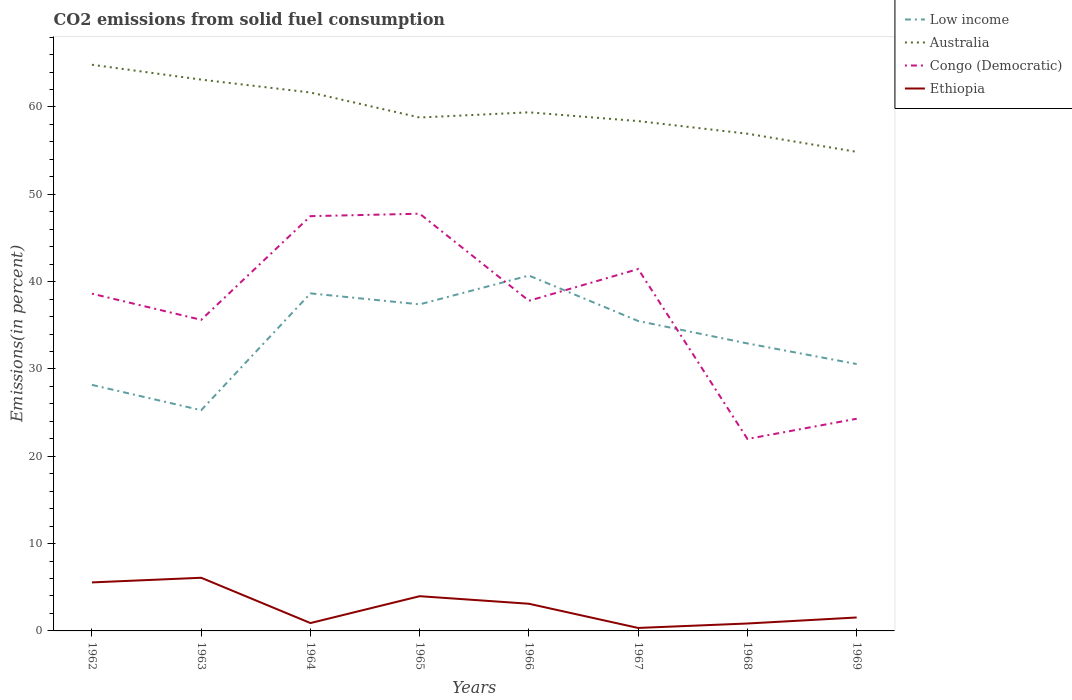Does the line corresponding to Ethiopia intersect with the line corresponding to Low income?
Your response must be concise. No. Across all years, what is the maximum total CO2 emitted in Australia?
Your answer should be compact. 54.86. In which year was the total CO2 emitted in Ethiopia maximum?
Ensure brevity in your answer.  1967. What is the total total CO2 emitted in Ethiopia in the graph?
Give a very brief answer. 3.64. What is the difference between the highest and the second highest total CO2 emitted in Ethiopia?
Your response must be concise. 5.75. What is the difference between the highest and the lowest total CO2 emitted in Low income?
Keep it short and to the point. 4. Is the total CO2 emitted in Ethiopia strictly greater than the total CO2 emitted in Low income over the years?
Offer a terse response. Yes. How many lines are there?
Provide a short and direct response. 4. How many legend labels are there?
Your answer should be very brief. 4. What is the title of the graph?
Make the answer very short. CO2 emissions from solid fuel consumption. Does "Sub-Saharan Africa (developing only)" appear as one of the legend labels in the graph?
Ensure brevity in your answer.  No. What is the label or title of the Y-axis?
Offer a very short reply. Emissions(in percent). What is the Emissions(in percent) in Low income in 1962?
Make the answer very short. 28.17. What is the Emissions(in percent) of Australia in 1962?
Give a very brief answer. 64.83. What is the Emissions(in percent) of Congo (Democratic) in 1962?
Your answer should be very brief. 38.62. What is the Emissions(in percent) in Ethiopia in 1962?
Offer a very short reply. 5.56. What is the Emissions(in percent) in Low income in 1963?
Give a very brief answer. 25.27. What is the Emissions(in percent) of Australia in 1963?
Provide a short and direct response. 63.13. What is the Emissions(in percent) of Congo (Democratic) in 1963?
Make the answer very short. 35.62. What is the Emissions(in percent) in Ethiopia in 1963?
Give a very brief answer. 6.09. What is the Emissions(in percent) in Low income in 1964?
Keep it short and to the point. 38.65. What is the Emissions(in percent) of Australia in 1964?
Ensure brevity in your answer.  61.65. What is the Emissions(in percent) in Congo (Democratic) in 1964?
Ensure brevity in your answer.  47.5. What is the Emissions(in percent) in Ethiopia in 1964?
Make the answer very short. 0.9. What is the Emissions(in percent) in Low income in 1965?
Provide a succinct answer. 37.4. What is the Emissions(in percent) in Australia in 1965?
Offer a very short reply. 58.79. What is the Emissions(in percent) of Congo (Democratic) in 1965?
Make the answer very short. 47.77. What is the Emissions(in percent) of Ethiopia in 1965?
Give a very brief answer. 3.98. What is the Emissions(in percent) of Low income in 1966?
Your answer should be compact. 40.69. What is the Emissions(in percent) of Australia in 1966?
Your response must be concise. 59.38. What is the Emissions(in percent) in Congo (Democratic) in 1966?
Give a very brief answer. 37.8. What is the Emissions(in percent) in Ethiopia in 1966?
Make the answer very short. 3.11. What is the Emissions(in percent) of Low income in 1967?
Keep it short and to the point. 35.49. What is the Emissions(in percent) of Australia in 1967?
Provide a short and direct response. 58.38. What is the Emissions(in percent) in Congo (Democratic) in 1967?
Keep it short and to the point. 41.44. What is the Emissions(in percent) in Ethiopia in 1967?
Keep it short and to the point. 0.34. What is the Emissions(in percent) in Low income in 1968?
Give a very brief answer. 32.92. What is the Emissions(in percent) of Australia in 1968?
Offer a terse response. 56.94. What is the Emissions(in percent) in Congo (Democratic) in 1968?
Make the answer very short. 21.98. What is the Emissions(in percent) of Ethiopia in 1968?
Offer a very short reply. 0.85. What is the Emissions(in percent) in Low income in 1969?
Your answer should be very brief. 30.56. What is the Emissions(in percent) of Australia in 1969?
Your answer should be very brief. 54.86. What is the Emissions(in percent) in Congo (Democratic) in 1969?
Make the answer very short. 24.3. What is the Emissions(in percent) of Ethiopia in 1969?
Your answer should be very brief. 1.54. Across all years, what is the maximum Emissions(in percent) of Low income?
Your answer should be compact. 40.69. Across all years, what is the maximum Emissions(in percent) in Australia?
Offer a terse response. 64.83. Across all years, what is the maximum Emissions(in percent) in Congo (Democratic)?
Your answer should be compact. 47.77. Across all years, what is the maximum Emissions(in percent) in Ethiopia?
Your answer should be very brief. 6.09. Across all years, what is the minimum Emissions(in percent) of Low income?
Your answer should be compact. 25.27. Across all years, what is the minimum Emissions(in percent) of Australia?
Ensure brevity in your answer.  54.86. Across all years, what is the minimum Emissions(in percent) in Congo (Democratic)?
Ensure brevity in your answer.  21.98. Across all years, what is the minimum Emissions(in percent) of Ethiopia?
Make the answer very short. 0.34. What is the total Emissions(in percent) in Low income in the graph?
Offer a terse response. 269.16. What is the total Emissions(in percent) in Australia in the graph?
Your response must be concise. 477.97. What is the total Emissions(in percent) in Congo (Democratic) in the graph?
Provide a succinct answer. 295.03. What is the total Emissions(in percent) in Ethiopia in the graph?
Ensure brevity in your answer.  22.36. What is the difference between the Emissions(in percent) in Low income in 1962 and that in 1963?
Offer a terse response. 2.9. What is the difference between the Emissions(in percent) of Australia in 1962 and that in 1963?
Your answer should be compact. 1.7. What is the difference between the Emissions(in percent) of Congo (Democratic) in 1962 and that in 1963?
Ensure brevity in your answer.  2.99. What is the difference between the Emissions(in percent) in Ethiopia in 1962 and that in 1963?
Offer a very short reply. -0.53. What is the difference between the Emissions(in percent) of Low income in 1962 and that in 1964?
Keep it short and to the point. -10.48. What is the difference between the Emissions(in percent) of Australia in 1962 and that in 1964?
Your answer should be compact. 3.18. What is the difference between the Emissions(in percent) of Congo (Democratic) in 1962 and that in 1964?
Your answer should be compact. -8.88. What is the difference between the Emissions(in percent) of Ethiopia in 1962 and that in 1964?
Offer a very short reply. 4.65. What is the difference between the Emissions(in percent) in Low income in 1962 and that in 1965?
Provide a short and direct response. -9.22. What is the difference between the Emissions(in percent) of Australia in 1962 and that in 1965?
Your answer should be compact. 6.04. What is the difference between the Emissions(in percent) in Congo (Democratic) in 1962 and that in 1965?
Keep it short and to the point. -9.16. What is the difference between the Emissions(in percent) in Ethiopia in 1962 and that in 1965?
Give a very brief answer. 1.58. What is the difference between the Emissions(in percent) in Low income in 1962 and that in 1966?
Provide a succinct answer. -12.52. What is the difference between the Emissions(in percent) of Australia in 1962 and that in 1966?
Keep it short and to the point. 5.45. What is the difference between the Emissions(in percent) in Congo (Democratic) in 1962 and that in 1966?
Keep it short and to the point. 0.81. What is the difference between the Emissions(in percent) of Ethiopia in 1962 and that in 1966?
Make the answer very short. 2.44. What is the difference between the Emissions(in percent) of Low income in 1962 and that in 1967?
Provide a succinct answer. -7.31. What is the difference between the Emissions(in percent) of Australia in 1962 and that in 1967?
Provide a succinct answer. 6.45. What is the difference between the Emissions(in percent) in Congo (Democratic) in 1962 and that in 1967?
Provide a short and direct response. -2.82. What is the difference between the Emissions(in percent) of Ethiopia in 1962 and that in 1967?
Give a very brief answer. 5.21. What is the difference between the Emissions(in percent) of Low income in 1962 and that in 1968?
Provide a short and direct response. -4.75. What is the difference between the Emissions(in percent) in Australia in 1962 and that in 1968?
Provide a short and direct response. 7.9. What is the difference between the Emissions(in percent) in Congo (Democratic) in 1962 and that in 1968?
Provide a succinct answer. 16.64. What is the difference between the Emissions(in percent) of Ethiopia in 1962 and that in 1968?
Ensure brevity in your answer.  4.71. What is the difference between the Emissions(in percent) of Low income in 1962 and that in 1969?
Provide a short and direct response. -2.39. What is the difference between the Emissions(in percent) of Australia in 1962 and that in 1969?
Make the answer very short. 9.98. What is the difference between the Emissions(in percent) of Congo (Democratic) in 1962 and that in 1969?
Your answer should be compact. 14.32. What is the difference between the Emissions(in percent) in Ethiopia in 1962 and that in 1969?
Give a very brief answer. 4.02. What is the difference between the Emissions(in percent) of Low income in 1963 and that in 1964?
Keep it short and to the point. -13.38. What is the difference between the Emissions(in percent) of Australia in 1963 and that in 1964?
Your response must be concise. 1.48. What is the difference between the Emissions(in percent) in Congo (Democratic) in 1963 and that in 1964?
Provide a short and direct response. -11.87. What is the difference between the Emissions(in percent) in Ethiopia in 1963 and that in 1964?
Offer a very short reply. 5.19. What is the difference between the Emissions(in percent) of Low income in 1963 and that in 1965?
Provide a succinct answer. -12.12. What is the difference between the Emissions(in percent) in Australia in 1963 and that in 1965?
Keep it short and to the point. 4.34. What is the difference between the Emissions(in percent) in Congo (Democratic) in 1963 and that in 1965?
Ensure brevity in your answer.  -12.15. What is the difference between the Emissions(in percent) in Ethiopia in 1963 and that in 1965?
Offer a terse response. 2.11. What is the difference between the Emissions(in percent) of Low income in 1963 and that in 1966?
Your answer should be compact. -15.42. What is the difference between the Emissions(in percent) in Australia in 1963 and that in 1966?
Give a very brief answer. 3.75. What is the difference between the Emissions(in percent) in Congo (Democratic) in 1963 and that in 1966?
Your answer should be very brief. -2.18. What is the difference between the Emissions(in percent) in Ethiopia in 1963 and that in 1966?
Your answer should be very brief. 2.98. What is the difference between the Emissions(in percent) in Low income in 1963 and that in 1967?
Give a very brief answer. -10.21. What is the difference between the Emissions(in percent) in Australia in 1963 and that in 1967?
Ensure brevity in your answer.  4.75. What is the difference between the Emissions(in percent) in Congo (Democratic) in 1963 and that in 1967?
Your response must be concise. -5.82. What is the difference between the Emissions(in percent) of Ethiopia in 1963 and that in 1967?
Your answer should be very brief. 5.75. What is the difference between the Emissions(in percent) of Low income in 1963 and that in 1968?
Your answer should be very brief. -7.65. What is the difference between the Emissions(in percent) of Australia in 1963 and that in 1968?
Your answer should be compact. 6.2. What is the difference between the Emissions(in percent) in Congo (Democratic) in 1963 and that in 1968?
Ensure brevity in your answer.  13.64. What is the difference between the Emissions(in percent) of Ethiopia in 1963 and that in 1968?
Keep it short and to the point. 5.24. What is the difference between the Emissions(in percent) of Low income in 1963 and that in 1969?
Your answer should be compact. -5.29. What is the difference between the Emissions(in percent) in Australia in 1963 and that in 1969?
Keep it short and to the point. 8.27. What is the difference between the Emissions(in percent) in Congo (Democratic) in 1963 and that in 1969?
Your answer should be very brief. 11.33. What is the difference between the Emissions(in percent) in Ethiopia in 1963 and that in 1969?
Your response must be concise. 4.55. What is the difference between the Emissions(in percent) in Low income in 1964 and that in 1965?
Provide a succinct answer. 1.26. What is the difference between the Emissions(in percent) of Australia in 1964 and that in 1965?
Provide a short and direct response. 2.86. What is the difference between the Emissions(in percent) of Congo (Democratic) in 1964 and that in 1965?
Offer a terse response. -0.28. What is the difference between the Emissions(in percent) of Ethiopia in 1964 and that in 1965?
Your response must be concise. -3.08. What is the difference between the Emissions(in percent) in Low income in 1964 and that in 1966?
Give a very brief answer. -2.04. What is the difference between the Emissions(in percent) of Australia in 1964 and that in 1966?
Make the answer very short. 2.27. What is the difference between the Emissions(in percent) of Congo (Democratic) in 1964 and that in 1966?
Offer a very short reply. 9.69. What is the difference between the Emissions(in percent) in Ethiopia in 1964 and that in 1966?
Offer a very short reply. -2.21. What is the difference between the Emissions(in percent) of Low income in 1964 and that in 1967?
Your response must be concise. 3.16. What is the difference between the Emissions(in percent) in Australia in 1964 and that in 1967?
Make the answer very short. 3.27. What is the difference between the Emissions(in percent) in Congo (Democratic) in 1964 and that in 1967?
Provide a succinct answer. 6.06. What is the difference between the Emissions(in percent) in Ethiopia in 1964 and that in 1967?
Offer a very short reply. 0.56. What is the difference between the Emissions(in percent) in Low income in 1964 and that in 1968?
Provide a succinct answer. 5.73. What is the difference between the Emissions(in percent) in Australia in 1964 and that in 1968?
Provide a short and direct response. 4.72. What is the difference between the Emissions(in percent) of Congo (Democratic) in 1964 and that in 1968?
Your response must be concise. 25.51. What is the difference between the Emissions(in percent) of Ethiopia in 1964 and that in 1968?
Provide a short and direct response. 0.05. What is the difference between the Emissions(in percent) in Low income in 1964 and that in 1969?
Make the answer very short. 8.09. What is the difference between the Emissions(in percent) of Australia in 1964 and that in 1969?
Make the answer very short. 6.8. What is the difference between the Emissions(in percent) in Congo (Democratic) in 1964 and that in 1969?
Make the answer very short. 23.2. What is the difference between the Emissions(in percent) in Ethiopia in 1964 and that in 1969?
Ensure brevity in your answer.  -0.64. What is the difference between the Emissions(in percent) of Low income in 1965 and that in 1966?
Give a very brief answer. -3.3. What is the difference between the Emissions(in percent) of Australia in 1965 and that in 1966?
Offer a very short reply. -0.59. What is the difference between the Emissions(in percent) of Congo (Democratic) in 1965 and that in 1966?
Offer a very short reply. 9.97. What is the difference between the Emissions(in percent) of Ethiopia in 1965 and that in 1966?
Give a very brief answer. 0.87. What is the difference between the Emissions(in percent) of Low income in 1965 and that in 1967?
Make the answer very short. 1.91. What is the difference between the Emissions(in percent) of Australia in 1965 and that in 1967?
Make the answer very short. 0.41. What is the difference between the Emissions(in percent) in Congo (Democratic) in 1965 and that in 1967?
Offer a terse response. 6.33. What is the difference between the Emissions(in percent) of Ethiopia in 1965 and that in 1967?
Provide a succinct answer. 3.64. What is the difference between the Emissions(in percent) of Low income in 1965 and that in 1968?
Provide a succinct answer. 4.48. What is the difference between the Emissions(in percent) in Australia in 1965 and that in 1968?
Your response must be concise. 1.86. What is the difference between the Emissions(in percent) of Congo (Democratic) in 1965 and that in 1968?
Provide a short and direct response. 25.79. What is the difference between the Emissions(in percent) in Ethiopia in 1965 and that in 1968?
Offer a terse response. 3.13. What is the difference between the Emissions(in percent) in Low income in 1965 and that in 1969?
Your response must be concise. 6.84. What is the difference between the Emissions(in percent) of Australia in 1965 and that in 1969?
Offer a very short reply. 3.93. What is the difference between the Emissions(in percent) in Congo (Democratic) in 1965 and that in 1969?
Provide a short and direct response. 23.48. What is the difference between the Emissions(in percent) of Ethiopia in 1965 and that in 1969?
Ensure brevity in your answer.  2.44. What is the difference between the Emissions(in percent) of Low income in 1966 and that in 1967?
Your answer should be very brief. 5.21. What is the difference between the Emissions(in percent) in Congo (Democratic) in 1966 and that in 1967?
Keep it short and to the point. -3.64. What is the difference between the Emissions(in percent) of Ethiopia in 1966 and that in 1967?
Provide a succinct answer. 2.77. What is the difference between the Emissions(in percent) in Low income in 1966 and that in 1968?
Ensure brevity in your answer.  7.77. What is the difference between the Emissions(in percent) of Australia in 1966 and that in 1968?
Provide a succinct answer. 2.45. What is the difference between the Emissions(in percent) of Congo (Democratic) in 1966 and that in 1968?
Provide a succinct answer. 15.82. What is the difference between the Emissions(in percent) in Ethiopia in 1966 and that in 1968?
Give a very brief answer. 2.26. What is the difference between the Emissions(in percent) in Low income in 1966 and that in 1969?
Ensure brevity in your answer.  10.13. What is the difference between the Emissions(in percent) of Australia in 1966 and that in 1969?
Your answer should be very brief. 4.53. What is the difference between the Emissions(in percent) of Congo (Democratic) in 1966 and that in 1969?
Make the answer very short. 13.51. What is the difference between the Emissions(in percent) in Ethiopia in 1966 and that in 1969?
Your answer should be very brief. 1.57. What is the difference between the Emissions(in percent) in Low income in 1967 and that in 1968?
Offer a terse response. 2.57. What is the difference between the Emissions(in percent) in Australia in 1967 and that in 1968?
Keep it short and to the point. 1.45. What is the difference between the Emissions(in percent) in Congo (Democratic) in 1967 and that in 1968?
Keep it short and to the point. 19.46. What is the difference between the Emissions(in percent) in Ethiopia in 1967 and that in 1968?
Your answer should be compact. -0.51. What is the difference between the Emissions(in percent) in Low income in 1967 and that in 1969?
Offer a terse response. 4.93. What is the difference between the Emissions(in percent) in Australia in 1967 and that in 1969?
Keep it short and to the point. 3.52. What is the difference between the Emissions(in percent) in Congo (Democratic) in 1967 and that in 1969?
Offer a terse response. 17.14. What is the difference between the Emissions(in percent) of Ethiopia in 1967 and that in 1969?
Make the answer very short. -1.2. What is the difference between the Emissions(in percent) of Low income in 1968 and that in 1969?
Offer a very short reply. 2.36. What is the difference between the Emissions(in percent) in Australia in 1968 and that in 1969?
Keep it short and to the point. 2.08. What is the difference between the Emissions(in percent) in Congo (Democratic) in 1968 and that in 1969?
Provide a succinct answer. -2.32. What is the difference between the Emissions(in percent) of Ethiopia in 1968 and that in 1969?
Provide a short and direct response. -0.69. What is the difference between the Emissions(in percent) in Low income in 1962 and the Emissions(in percent) in Australia in 1963?
Ensure brevity in your answer.  -34.96. What is the difference between the Emissions(in percent) in Low income in 1962 and the Emissions(in percent) in Congo (Democratic) in 1963?
Give a very brief answer. -7.45. What is the difference between the Emissions(in percent) in Low income in 1962 and the Emissions(in percent) in Ethiopia in 1963?
Your answer should be compact. 22.09. What is the difference between the Emissions(in percent) in Australia in 1962 and the Emissions(in percent) in Congo (Democratic) in 1963?
Provide a succinct answer. 29.21. What is the difference between the Emissions(in percent) of Australia in 1962 and the Emissions(in percent) of Ethiopia in 1963?
Keep it short and to the point. 58.75. What is the difference between the Emissions(in percent) of Congo (Democratic) in 1962 and the Emissions(in percent) of Ethiopia in 1963?
Give a very brief answer. 32.53. What is the difference between the Emissions(in percent) in Low income in 1962 and the Emissions(in percent) in Australia in 1964?
Make the answer very short. -33.48. What is the difference between the Emissions(in percent) in Low income in 1962 and the Emissions(in percent) in Congo (Democratic) in 1964?
Offer a terse response. -19.32. What is the difference between the Emissions(in percent) in Low income in 1962 and the Emissions(in percent) in Ethiopia in 1964?
Keep it short and to the point. 27.27. What is the difference between the Emissions(in percent) of Australia in 1962 and the Emissions(in percent) of Congo (Democratic) in 1964?
Ensure brevity in your answer.  17.34. What is the difference between the Emissions(in percent) in Australia in 1962 and the Emissions(in percent) in Ethiopia in 1964?
Give a very brief answer. 63.93. What is the difference between the Emissions(in percent) of Congo (Democratic) in 1962 and the Emissions(in percent) of Ethiopia in 1964?
Your response must be concise. 37.72. What is the difference between the Emissions(in percent) of Low income in 1962 and the Emissions(in percent) of Australia in 1965?
Your response must be concise. -30.62. What is the difference between the Emissions(in percent) in Low income in 1962 and the Emissions(in percent) in Congo (Democratic) in 1965?
Your response must be concise. -19.6. What is the difference between the Emissions(in percent) in Low income in 1962 and the Emissions(in percent) in Ethiopia in 1965?
Provide a short and direct response. 24.2. What is the difference between the Emissions(in percent) of Australia in 1962 and the Emissions(in percent) of Congo (Democratic) in 1965?
Make the answer very short. 17.06. What is the difference between the Emissions(in percent) of Australia in 1962 and the Emissions(in percent) of Ethiopia in 1965?
Make the answer very short. 60.86. What is the difference between the Emissions(in percent) in Congo (Democratic) in 1962 and the Emissions(in percent) in Ethiopia in 1965?
Keep it short and to the point. 34.64. What is the difference between the Emissions(in percent) of Low income in 1962 and the Emissions(in percent) of Australia in 1966?
Your response must be concise. -31.21. What is the difference between the Emissions(in percent) of Low income in 1962 and the Emissions(in percent) of Congo (Democratic) in 1966?
Offer a very short reply. -9.63. What is the difference between the Emissions(in percent) of Low income in 1962 and the Emissions(in percent) of Ethiopia in 1966?
Provide a succinct answer. 25.06. What is the difference between the Emissions(in percent) of Australia in 1962 and the Emissions(in percent) of Congo (Democratic) in 1966?
Your answer should be very brief. 27.03. What is the difference between the Emissions(in percent) in Australia in 1962 and the Emissions(in percent) in Ethiopia in 1966?
Your answer should be compact. 61.72. What is the difference between the Emissions(in percent) in Congo (Democratic) in 1962 and the Emissions(in percent) in Ethiopia in 1966?
Provide a succinct answer. 35.51. What is the difference between the Emissions(in percent) in Low income in 1962 and the Emissions(in percent) in Australia in 1967?
Your response must be concise. -30.21. What is the difference between the Emissions(in percent) in Low income in 1962 and the Emissions(in percent) in Congo (Democratic) in 1967?
Your response must be concise. -13.27. What is the difference between the Emissions(in percent) of Low income in 1962 and the Emissions(in percent) of Ethiopia in 1967?
Your answer should be compact. 27.83. What is the difference between the Emissions(in percent) in Australia in 1962 and the Emissions(in percent) in Congo (Democratic) in 1967?
Offer a very short reply. 23.39. What is the difference between the Emissions(in percent) of Australia in 1962 and the Emissions(in percent) of Ethiopia in 1967?
Your answer should be very brief. 64.49. What is the difference between the Emissions(in percent) in Congo (Democratic) in 1962 and the Emissions(in percent) in Ethiopia in 1967?
Make the answer very short. 38.28. What is the difference between the Emissions(in percent) in Low income in 1962 and the Emissions(in percent) in Australia in 1968?
Provide a succinct answer. -28.76. What is the difference between the Emissions(in percent) of Low income in 1962 and the Emissions(in percent) of Congo (Democratic) in 1968?
Your answer should be compact. 6.19. What is the difference between the Emissions(in percent) of Low income in 1962 and the Emissions(in percent) of Ethiopia in 1968?
Keep it short and to the point. 27.32. What is the difference between the Emissions(in percent) of Australia in 1962 and the Emissions(in percent) of Congo (Democratic) in 1968?
Your answer should be very brief. 42.85. What is the difference between the Emissions(in percent) of Australia in 1962 and the Emissions(in percent) of Ethiopia in 1968?
Keep it short and to the point. 63.98. What is the difference between the Emissions(in percent) of Congo (Democratic) in 1962 and the Emissions(in percent) of Ethiopia in 1968?
Give a very brief answer. 37.77. What is the difference between the Emissions(in percent) of Low income in 1962 and the Emissions(in percent) of Australia in 1969?
Make the answer very short. -26.68. What is the difference between the Emissions(in percent) in Low income in 1962 and the Emissions(in percent) in Congo (Democratic) in 1969?
Your answer should be compact. 3.88. What is the difference between the Emissions(in percent) of Low income in 1962 and the Emissions(in percent) of Ethiopia in 1969?
Give a very brief answer. 26.64. What is the difference between the Emissions(in percent) in Australia in 1962 and the Emissions(in percent) in Congo (Democratic) in 1969?
Your answer should be compact. 40.54. What is the difference between the Emissions(in percent) of Australia in 1962 and the Emissions(in percent) of Ethiopia in 1969?
Provide a succinct answer. 63.3. What is the difference between the Emissions(in percent) of Congo (Democratic) in 1962 and the Emissions(in percent) of Ethiopia in 1969?
Your response must be concise. 37.08. What is the difference between the Emissions(in percent) in Low income in 1963 and the Emissions(in percent) in Australia in 1964?
Provide a short and direct response. -36.38. What is the difference between the Emissions(in percent) in Low income in 1963 and the Emissions(in percent) in Congo (Democratic) in 1964?
Ensure brevity in your answer.  -22.22. What is the difference between the Emissions(in percent) in Low income in 1963 and the Emissions(in percent) in Ethiopia in 1964?
Give a very brief answer. 24.37. What is the difference between the Emissions(in percent) of Australia in 1963 and the Emissions(in percent) of Congo (Democratic) in 1964?
Make the answer very short. 15.63. What is the difference between the Emissions(in percent) of Australia in 1963 and the Emissions(in percent) of Ethiopia in 1964?
Offer a terse response. 62.23. What is the difference between the Emissions(in percent) of Congo (Democratic) in 1963 and the Emissions(in percent) of Ethiopia in 1964?
Provide a succinct answer. 34.72. What is the difference between the Emissions(in percent) of Low income in 1963 and the Emissions(in percent) of Australia in 1965?
Offer a very short reply. -33.52. What is the difference between the Emissions(in percent) of Low income in 1963 and the Emissions(in percent) of Congo (Democratic) in 1965?
Offer a very short reply. -22.5. What is the difference between the Emissions(in percent) in Low income in 1963 and the Emissions(in percent) in Ethiopia in 1965?
Offer a terse response. 21.3. What is the difference between the Emissions(in percent) of Australia in 1963 and the Emissions(in percent) of Congo (Democratic) in 1965?
Your answer should be compact. 15.36. What is the difference between the Emissions(in percent) in Australia in 1963 and the Emissions(in percent) in Ethiopia in 1965?
Your answer should be compact. 59.15. What is the difference between the Emissions(in percent) of Congo (Democratic) in 1963 and the Emissions(in percent) of Ethiopia in 1965?
Ensure brevity in your answer.  31.65. What is the difference between the Emissions(in percent) in Low income in 1963 and the Emissions(in percent) in Australia in 1966?
Ensure brevity in your answer.  -34.11. What is the difference between the Emissions(in percent) in Low income in 1963 and the Emissions(in percent) in Congo (Democratic) in 1966?
Ensure brevity in your answer.  -12.53. What is the difference between the Emissions(in percent) in Low income in 1963 and the Emissions(in percent) in Ethiopia in 1966?
Offer a terse response. 22.16. What is the difference between the Emissions(in percent) in Australia in 1963 and the Emissions(in percent) in Congo (Democratic) in 1966?
Make the answer very short. 25.33. What is the difference between the Emissions(in percent) of Australia in 1963 and the Emissions(in percent) of Ethiopia in 1966?
Your answer should be compact. 60.02. What is the difference between the Emissions(in percent) of Congo (Democratic) in 1963 and the Emissions(in percent) of Ethiopia in 1966?
Make the answer very short. 32.51. What is the difference between the Emissions(in percent) in Low income in 1963 and the Emissions(in percent) in Australia in 1967?
Keep it short and to the point. -33.11. What is the difference between the Emissions(in percent) of Low income in 1963 and the Emissions(in percent) of Congo (Democratic) in 1967?
Ensure brevity in your answer.  -16.17. What is the difference between the Emissions(in percent) of Low income in 1963 and the Emissions(in percent) of Ethiopia in 1967?
Your answer should be compact. 24.93. What is the difference between the Emissions(in percent) in Australia in 1963 and the Emissions(in percent) in Congo (Democratic) in 1967?
Give a very brief answer. 21.69. What is the difference between the Emissions(in percent) in Australia in 1963 and the Emissions(in percent) in Ethiopia in 1967?
Provide a succinct answer. 62.79. What is the difference between the Emissions(in percent) in Congo (Democratic) in 1963 and the Emissions(in percent) in Ethiopia in 1967?
Your answer should be compact. 35.28. What is the difference between the Emissions(in percent) in Low income in 1963 and the Emissions(in percent) in Australia in 1968?
Your response must be concise. -31.66. What is the difference between the Emissions(in percent) of Low income in 1963 and the Emissions(in percent) of Congo (Democratic) in 1968?
Offer a very short reply. 3.29. What is the difference between the Emissions(in percent) of Low income in 1963 and the Emissions(in percent) of Ethiopia in 1968?
Your answer should be very brief. 24.43. What is the difference between the Emissions(in percent) of Australia in 1963 and the Emissions(in percent) of Congo (Democratic) in 1968?
Ensure brevity in your answer.  41.15. What is the difference between the Emissions(in percent) in Australia in 1963 and the Emissions(in percent) in Ethiopia in 1968?
Your response must be concise. 62.28. What is the difference between the Emissions(in percent) of Congo (Democratic) in 1963 and the Emissions(in percent) of Ethiopia in 1968?
Your answer should be very brief. 34.77. What is the difference between the Emissions(in percent) of Low income in 1963 and the Emissions(in percent) of Australia in 1969?
Provide a succinct answer. -29.58. What is the difference between the Emissions(in percent) in Low income in 1963 and the Emissions(in percent) in Congo (Democratic) in 1969?
Offer a very short reply. 0.98. What is the difference between the Emissions(in percent) in Low income in 1963 and the Emissions(in percent) in Ethiopia in 1969?
Make the answer very short. 23.74. What is the difference between the Emissions(in percent) of Australia in 1963 and the Emissions(in percent) of Congo (Democratic) in 1969?
Keep it short and to the point. 38.83. What is the difference between the Emissions(in percent) in Australia in 1963 and the Emissions(in percent) in Ethiopia in 1969?
Provide a succinct answer. 61.59. What is the difference between the Emissions(in percent) of Congo (Democratic) in 1963 and the Emissions(in percent) of Ethiopia in 1969?
Your response must be concise. 34.08. What is the difference between the Emissions(in percent) of Low income in 1964 and the Emissions(in percent) of Australia in 1965?
Your answer should be compact. -20.14. What is the difference between the Emissions(in percent) in Low income in 1964 and the Emissions(in percent) in Congo (Democratic) in 1965?
Offer a terse response. -9.12. What is the difference between the Emissions(in percent) of Low income in 1964 and the Emissions(in percent) of Ethiopia in 1965?
Your response must be concise. 34.67. What is the difference between the Emissions(in percent) of Australia in 1964 and the Emissions(in percent) of Congo (Democratic) in 1965?
Provide a short and direct response. 13.88. What is the difference between the Emissions(in percent) in Australia in 1964 and the Emissions(in percent) in Ethiopia in 1965?
Your response must be concise. 57.68. What is the difference between the Emissions(in percent) of Congo (Democratic) in 1964 and the Emissions(in percent) of Ethiopia in 1965?
Make the answer very short. 43.52. What is the difference between the Emissions(in percent) of Low income in 1964 and the Emissions(in percent) of Australia in 1966?
Make the answer very short. -20.73. What is the difference between the Emissions(in percent) in Low income in 1964 and the Emissions(in percent) in Congo (Democratic) in 1966?
Offer a very short reply. 0.85. What is the difference between the Emissions(in percent) of Low income in 1964 and the Emissions(in percent) of Ethiopia in 1966?
Give a very brief answer. 35.54. What is the difference between the Emissions(in percent) of Australia in 1964 and the Emissions(in percent) of Congo (Democratic) in 1966?
Your answer should be very brief. 23.85. What is the difference between the Emissions(in percent) in Australia in 1964 and the Emissions(in percent) in Ethiopia in 1966?
Your answer should be compact. 58.54. What is the difference between the Emissions(in percent) in Congo (Democratic) in 1964 and the Emissions(in percent) in Ethiopia in 1966?
Provide a succinct answer. 44.38. What is the difference between the Emissions(in percent) of Low income in 1964 and the Emissions(in percent) of Australia in 1967?
Your answer should be very brief. -19.73. What is the difference between the Emissions(in percent) of Low income in 1964 and the Emissions(in percent) of Congo (Democratic) in 1967?
Make the answer very short. -2.79. What is the difference between the Emissions(in percent) of Low income in 1964 and the Emissions(in percent) of Ethiopia in 1967?
Provide a succinct answer. 38.31. What is the difference between the Emissions(in percent) of Australia in 1964 and the Emissions(in percent) of Congo (Democratic) in 1967?
Keep it short and to the point. 20.21. What is the difference between the Emissions(in percent) of Australia in 1964 and the Emissions(in percent) of Ethiopia in 1967?
Keep it short and to the point. 61.31. What is the difference between the Emissions(in percent) in Congo (Democratic) in 1964 and the Emissions(in percent) in Ethiopia in 1967?
Your response must be concise. 47.15. What is the difference between the Emissions(in percent) of Low income in 1964 and the Emissions(in percent) of Australia in 1968?
Give a very brief answer. -18.28. What is the difference between the Emissions(in percent) of Low income in 1964 and the Emissions(in percent) of Congo (Democratic) in 1968?
Provide a succinct answer. 16.67. What is the difference between the Emissions(in percent) in Low income in 1964 and the Emissions(in percent) in Ethiopia in 1968?
Your answer should be very brief. 37.8. What is the difference between the Emissions(in percent) of Australia in 1964 and the Emissions(in percent) of Congo (Democratic) in 1968?
Your response must be concise. 39.67. What is the difference between the Emissions(in percent) of Australia in 1964 and the Emissions(in percent) of Ethiopia in 1968?
Ensure brevity in your answer.  60.8. What is the difference between the Emissions(in percent) in Congo (Democratic) in 1964 and the Emissions(in percent) in Ethiopia in 1968?
Offer a very short reply. 46.65. What is the difference between the Emissions(in percent) in Low income in 1964 and the Emissions(in percent) in Australia in 1969?
Your answer should be compact. -16.21. What is the difference between the Emissions(in percent) in Low income in 1964 and the Emissions(in percent) in Congo (Democratic) in 1969?
Your response must be concise. 14.35. What is the difference between the Emissions(in percent) in Low income in 1964 and the Emissions(in percent) in Ethiopia in 1969?
Offer a terse response. 37.11. What is the difference between the Emissions(in percent) in Australia in 1964 and the Emissions(in percent) in Congo (Democratic) in 1969?
Provide a succinct answer. 37.36. What is the difference between the Emissions(in percent) in Australia in 1964 and the Emissions(in percent) in Ethiopia in 1969?
Offer a very short reply. 60.12. What is the difference between the Emissions(in percent) of Congo (Democratic) in 1964 and the Emissions(in percent) of Ethiopia in 1969?
Make the answer very short. 45.96. What is the difference between the Emissions(in percent) of Low income in 1965 and the Emissions(in percent) of Australia in 1966?
Make the answer very short. -21.99. What is the difference between the Emissions(in percent) in Low income in 1965 and the Emissions(in percent) in Congo (Democratic) in 1966?
Keep it short and to the point. -0.41. What is the difference between the Emissions(in percent) of Low income in 1965 and the Emissions(in percent) of Ethiopia in 1966?
Provide a short and direct response. 34.29. What is the difference between the Emissions(in percent) of Australia in 1965 and the Emissions(in percent) of Congo (Democratic) in 1966?
Give a very brief answer. 20.99. What is the difference between the Emissions(in percent) of Australia in 1965 and the Emissions(in percent) of Ethiopia in 1966?
Your answer should be very brief. 55.68. What is the difference between the Emissions(in percent) of Congo (Democratic) in 1965 and the Emissions(in percent) of Ethiopia in 1966?
Keep it short and to the point. 44.66. What is the difference between the Emissions(in percent) in Low income in 1965 and the Emissions(in percent) in Australia in 1967?
Provide a succinct answer. -20.99. What is the difference between the Emissions(in percent) of Low income in 1965 and the Emissions(in percent) of Congo (Democratic) in 1967?
Ensure brevity in your answer.  -4.04. What is the difference between the Emissions(in percent) in Low income in 1965 and the Emissions(in percent) in Ethiopia in 1967?
Keep it short and to the point. 37.05. What is the difference between the Emissions(in percent) of Australia in 1965 and the Emissions(in percent) of Congo (Democratic) in 1967?
Ensure brevity in your answer.  17.35. What is the difference between the Emissions(in percent) of Australia in 1965 and the Emissions(in percent) of Ethiopia in 1967?
Offer a very short reply. 58.45. What is the difference between the Emissions(in percent) in Congo (Democratic) in 1965 and the Emissions(in percent) in Ethiopia in 1967?
Provide a short and direct response. 47.43. What is the difference between the Emissions(in percent) in Low income in 1965 and the Emissions(in percent) in Australia in 1968?
Your answer should be very brief. -19.54. What is the difference between the Emissions(in percent) in Low income in 1965 and the Emissions(in percent) in Congo (Democratic) in 1968?
Your answer should be very brief. 15.42. What is the difference between the Emissions(in percent) of Low income in 1965 and the Emissions(in percent) of Ethiopia in 1968?
Offer a very short reply. 36.55. What is the difference between the Emissions(in percent) of Australia in 1965 and the Emissions(in percent) of Congo (Democratic) in 1968?
Offer a very short reply. 36.81. What is the difference between the Emissions(in percent) of Australia in 1965 and the Emissions(in percent) of Ethiopia in 1968?
Make the answer very short. 57.94. What is the difference between the Emissions(in percent) in Congo (Democratic) in 1965 and the Emissions(in percent) in Ethiopia in 1968?
Give a very brief answer. 46.93. What is the difference between the Emissions(in percent) in Low income in 1965 and the Emissions(in percent) in Australia in 1969?
Offer a very short reply. -17.46. What is the difference between the Emissions(in percent) in Low income in 1965 and the Emissions(in percent) in Congo (Democratic) in 1969?
Ensure brevity in your answer.  13.1. What is the difference between the Emissions(in percent) in Low income in 1965 and the Emissions(in percent) in Ethiopia in 1969?
Provide a short and direct response. 35.86. What is the difference between the Emissions(in percent) in Australia in 1965 and the Emissions(in percent) in Congo (Democratic) in 1969?
Make the answer very short. 34.49. What is the difference between the Emissions(in percent) of Australia in 1965 and the Emissions(in percent) of Ethiopia in 1969?
Give a very brief answer. 57.25. What is the difference between the Emissions(in percent) of Congo (Democratic) in 1965 and the Emissions(in percent) of Ethiopia in 1969?
Provide a short and direct response. 46.24. What is the difference between the Emissions(in percent) of Low income in 1966 and the Emissions(in percent) of Australia in 1967?
Your response must be concise. -17.69. What is the difference between the Emissions(in percent) in Low income in 1966 and the Emissions(in percent) in Congo (Democratic) in 1967?
Your response must be concise. -0.75. What is the difference between the Emissions(in percent) of Low income in 1966 and the Emissions(in percent) of Ethiopia in 1967?
Your response must be concise. 40.35. What is the difference between the Emissions(in percent) of Australia in 1966 and the Emissions(in percent) of Congo (Democratic) in 1967?
Make the answer very short. 17.94. What is the difference between the Emissions(in percent) of Australia in 1966 and the Emissions(in percent) of Ethiopia in 1967?
Keep it short and to the point. 59.04. What is the difference between the Emissions(in percent) in Congo (Democratic) in 1966 and the Emissions(in percent) in Ethiopia in 1967?
Ensure brevity in your answer.  37.46. What is the difference between the Emissions(in percent) in Low income in 1966 and the Emissions(in percent) in Australia in 1968?
Offer a terse response. -16.24. What is the difference between the Emissions(in percent) of Low income in 1966 and the Emissions(in percent) of Congo (Democratic) in 1968?
Your response must be concise. 18.71. What is the difference between the Emissions(in percent) of Low income in 1966 and the Emissions(in percent) of Ethiopia in 1968?
Provide a short and direct response. 39.84. What is the difference between the Emissions(in percent) in Australia in 1966 and the Emissions(in percent) in Congo (Democratic) in 1968?
Give a very brief answer. 37.4. What is the difference between the Emissions(in percent) in Australia in 1966 and the Emissions(in percent) in Ethiopia in 1968?
Your answer should be very brief. 58.54. What is the difference between the Emissions(in percent) in Congo (Democratic) in 1966 and the Emissions(in percent) in Ethiopia in 1968?
Ensure brevity in your answer.  36.96. What is the difference between the Emissions(in percent) in Low income in 1966 and the Emissions(in percent) in Australia in 1969?
Your answer should be very brief. -14.17. What is the difference between the Emissions(in percent) of Low income in 1966 and the Emissions(in percent) of Congo (Democratic) in 1969?
Your response must be concise. 16.4. What is the difference between the Emissions(in percent) in Low income in 1966 and the Emissions(in percent) in Ethiopia in 1969?
Give a very brief answer. 39.16. What is the difference between the Emissions(in percent) in Australia in 1966 and the Emissions(in percent) in Congo (Democratic) in 1969?
Provide a succinct answer. 35.09. What is the difference between the Emissions(in percent) in Australia in 1966 and the Emissions(in percent) in Ethiopia in 1969?
Give a very brief answer. 57.85. What is the difference between the Emissions(in percent) of Congo (Democratic) in 1966 and the Emissions(in percent) of Ethiopia in 1969?
Ensure brevity in your answer.  36.27. What is the difference between the Emissions(in percent) in Low income in 1967 and the Emissions(in percent) in Australia in 1968?
Provide a succinct answer. -21.45. What is the difference between the Emissions(in percent) in Low income in 1967 and the Emissions(in percent) in Congo (Democratic) in 1968?
Keep it short and to the point. 13.51. What is the difference between the Emissions(in percent) of Low income in 1967 and the Emissions(in percent) of Ethiopia in 1968?
Ensure brevity in your answer.  34.64. What is the difference between the Emissions(in percent) of Australia in 1967 and the Emissions(in percent) of Congo (Democratic) in 1968?
Make the answer very short. 36.4. What is the difference between the Emissions(in percent) of Australia in 1967 and the Emissions(in percent) of Ethiopia in 1968?
Provide a succinct answer. 57.53. What is the difference between the Emissions(in percent) of Congo (Democratic) in 1967 and the Emissions(in percent) of Ethiopia in 1968?
Keep it short and to the point. 40.59. What is the difference between the Emissions(in percent) in Low income in 1967 and the Emissions(in percent) in Australia in 1969?
Provide a short and direct response. -19.37. What is the difference between the Emissions(in percent) in Low income in 1967 and the Emissions(in percent) in Congo (Democratic) in 1969?
Make the answer very short. 11.19. What is the difference between the Emissions(in percent) in Low income in 1967 and the Emissions(in percent) in Ethiopia in 1969?
Offer a very short reply. 33.95. What is the difference between the Emissions(in percent) in Australia in 1967 and the Emissions(in percent) in Congo (Democratic) in 1969?
Ensure brevity in your answer.  34.08. What is the difference between the Emissions(in percent) of Australia in 1967 and the Emissions(in percent) of Ethiopia in 1969?
Provide a succinct answer. 56.84. What is the difference between the Emissions(in percent) of Congo (Democratic) in 1967 and the Emissions(in percent) of Ethiopia in 1969?
Keep it short and to the point. 39.9. What is the difference between the Emissions(in percent) of Low income in 1968 and the Emissions(in percent) of Australia in 1969?
Keep it short and to the point. -21.94. What is the difference between the Emissions(in percent) in Low income in 1968 and the Emissions(in percent) in Congo (Democratic) in 1969?
Offer a very short reply. 8.62. What is the difference between the Emissions(in percent) in Low income in 1968 and the Emissions(in percent) in Ethiopia in 1969?
Make the answer very short. 31.38. What is the difference between the Emissions(in percent) in Australia in 1968 and the Emissions(in percent) in Congo (Democratic) in 1969?
Provide a short and direct response. 32.64. What is the difference between the Emissions(in percent) of Australia in 1968 and the Emissions(in percent) of Ethiopia in 1969?
Provide a short and direct response. 55.4. What is the difference between the Emissions(in percent) in Congo (Democratic) in 1968 and the Emissions(in percent) in Ethiopia in 1969?
Keep it short and to the point. 20.44. What is the average Emissions(in percent) in Low income per year?
Your response must be concise. 33.65. What is the average Emissions(in percent) in Australia per year?
Your answer should be compact. 59.75. What is the average Emissions(in percent) of Congo (Democratic) per year?
Provide a short and direct response. 36.88. What is the average Emissions(in percent) of Ethiopia per year?
Provide a short and direct response. 2.8. In the year 1962, what is the difference between the Emissions(in percent) of Low income and Emissions(in percent) of Australia?
Keep it short and to the point. -36.66. In the year 1962, what is the difference between the Emissions(in percent) of Low income and Emissions(in percent) of Congo (Democratic)?
Your response must be concise. -10.44. In the year 1962, what is the difference between the Emissions(in percent) of Low income and Emissions(in percent) of Ethiopia?
Give a very brief answer. 22.62. In the year 1962, what is the difference between the Emissions(in percent) of Australia and Emissions(in percent) of Congo (Democratic)?
Offer a terse response. 26.22. In the year 1962, what is the difference between the Emissions(in percent) of Australia and Emissions(in percent) of Ethiopia?
Provide a succinct answer. 59.28. In the year 1962, what is the difference between the Emissions(in percent) of Congo (Democratic) and Emissions(in percent) of Ethiopia?
Provide a succinct answer. 33.06. In the year 1963, what is the difference between the Emissions(in percent) in Low income and Emissions(in percent) in Australia?
Provide a succinct answer. -37.86. In the year 1963, what is the difference between the Emissions(in percent) of Low income and Emissions(in percent) of Congo (Democratic)?
Provide a short and direct response. -10.35. In the year 1963, what is the difference between the Emissions(in percent) of Low income and Emissions(in percent) of Ethiopia?
Keep it short and to the point. 19.19. In the year 1963, what is the difference between the Emissions(in percent) of Australia and Emissions(in percent) of Congo (Democratic)?
Make the answer very short. 27.51. In the year 1963, what is the difference between the Emissions(in percent) of Australia and Emissions(in percent) of Ethiopia?
Make the answer very short. 57.04. In the year 1963, what is the difference between the Emissions(in percent) of Congo (Democratic) and Emissions(in percent) of Ethiopia?
Give a very brief answer. 29.54. In the year 1964, what is the difference between the Emissions(in percent) of Low income and Emissions(in percent) of Australia?
Offer a terse response. -23. In the year 1964, what is the difference between the Emissions(in percent) of Low income and Emissions(in percent) of Congo (Democratic)?
Offer a very short reply. -8.84. In the year 1964, what is the difference between the Emissions(in percent) in Low income and Emissions(in percent) in Ethiopia?
Your answer should be very brief. 37.75. In the year 1964, what is the difference between the Emissions(in percent) in Australia and Emissions(in percent) in Congo (Democratic)?
Keep it short and to the point. 14.16. In the year 1964, what is the difference between the Emissions(in percent) of Australia and Emissions(in percent) of Ethiopia?
Ensure brevity in your answer.  60.75. In the year 1964, what is the difference between the Emissions(in percent) of Congo (Democratic) and Emissions(in percent) of Ethiopia?
Provide a succinct answer. 46.59. In the year 1965, what is the difference between the Emissions(in percent) in Low income and Emissions(in percent) in Australia?
Your answer should be compact. -21.39. In the year 1965, what is the difference between the Emissions(in percent) of Low income and Emissions(in percent) of Congo (Democratic)?
Your answer should be compact. -10.38. In the year 1965, what is the difference between the Emissions(in percent) in Low income and Emissions(in percent) in Ethiopia?
Provide a succinct answer. 33.42. In the year 1965, what is the difference between the Emissions(in percent) of Australia and Emissions(in percent) of Congo (Democratic)?
Keep it short and to the point. 11.02. In the year 1965, what is the difference between the Emissions(in percent) of Australia and Emissions(in percent) of Ethiopia?
Provide a short and direct response. 54.81. In the year 1965, what is the difference between the Emissions(in percent) in Congo (Democratic) and Emissions(in percent) in Ethiopia?
Keep it short and to the point. 43.8. In the year 1966, what is the difference between the Emissions(in percent) of Low income and Emissions(in percent) of Australia?
Offer a terse response. -18.69. In the year 1966, what is the difference between the Emissions(in percent) in Low income and Emissions(in percent) in Congo (Democratic)?
Your answer should be very brief. 2.89. In the year 1966, what is the difference between the Emissions(in percent) in Low income and Emissions(in percent) in Ethiopia?
Your answer should be compact. 37.58. In the year 1966, what is the difference between the Emissions(in percent) of Australia and Emissions(in percent) of Congo (Democratic)?
Your answer should be very brief. 21.58. In the year 1966, what is the difference between the Emissions(in percent) of Australia and Emissions(in percent) of Ethiopia?
Offer a terse response. 56.27. In the year 1966, what is the difference between the Emissions(in percent) in Congo (Democratic) and Emissions(in percent) in Ethiopia?
Make the answer very short. 34.69. In the year 1967, what is the difference between the Emissions(in percent) of Low income and Emissions(in percent) of Australia?
Your answer should be compact. -22.89. In the year 1967, what is the difference between the Emissions(in percent) in Low income and Emissions(in percent) in Congo (Democratic)?
Keep it short and to the point. -5.95. In the year 1967, what is the difference between the Emissions(in percent) of Low income and Emissions(in percent) of Ethiopia?
Provide a short and direct response. 35.15. In the year 1967, what is the difference between the Emissions(in percent) of Australia and Emissions(in percent) of Congo (Democratic)?
Provide a short and direct response. 16.94. In the year 1967, what is the difference between the Emissions(in percent) in Australia and Emissions(in percent) in Ethiopia?
Make the answer very short. 58.04. In the year 1967, what is the difference between the Emissions(in percent) in Congo (Democratic) and Emissions(in percent) in Ethiopia?
Give a very brief answer. 41.1. In the year 1968, what is the difference between the Emissions(in percent) of Low income and Emissions(in percent) of Australia?
Keep it short and to the point. -24.02. In the year 1968, what is the difference between the Emissions(in percent) in Low income and Emissions(in percent) in Congo (Democratic)?
Make the answer very short. 10.94. In the year 1968, what is the difference between the Emissions(in percent) in Low income and Emissions(in percent) in Ethiopia?
Provide a short and direct response. 32.07. In the year 1968, what is the difference between the Emissions(in percent) of Australia and Emissions(in percent) of Congo (Democratic)?
Make the answer very short. 34.95. In the year 1968, what is the difference between the Emissions(in percent) in Australia and Emissions(in percent) in Ethiopia?
Offer a very short reply. 56.09. In the year 1968, what is the difference between the Emissions(in percent) of Congo (Democratic) and Emissions(in percent) of Ethiopia?
Give a very brief answer. 21.13. In the year 1969, what is the difference between the Emissions(in percent) of Low income and Emissions(in percent) of Australia?
Ensure brevity in your answer.  -24.3. In the year 1969, what is the difference between the Emissions(in percent) of Low income and Emissions(in percent) of Congo (Democratic)?
Your answer should be very brief. 6.26. In the year 1969, what is the difference between the Emissions(in percent) of Low income and Emissions(in percent) of Ethiopia?
Provide a succinct answer. 29.02. In the year 1969, what is the difference between the Emissions(in percent) of Australia and Emissions(in percent) of Congo (Democratic)?
Your response must be concise. 30.56. In the year 1969, what is the difference between the Emissions(in percent) in Australia and Emissions(in percent) in Ethiopia?
Ensure brevity in your answer.  53.32. In the year 1969, what is the difference between the Emissions(in percent) in Congo (Democratic) and Emissions(in percent) in Ethiopia?
Give a very brief answer. 22.76. What is the ratio of the Emissions(in percent) in Low income in 1962 to that in 1963?
Make the answer very short. 1.11. What is the ratio of the Emissions(in percent) in Australia in 1962 to that in 1963?
Give a very brief answer. 1.03. What is the ratio of the Emissions(in percent) in Congo (Democratic) in 1962 to that in 1963?
Offer a very short reply. 1.08. What is the ratio of the Emissions(in percent) in Ethiopia in 1962 to that in 1963?
Make the answer very short. 0.91. What is the ratio of the Emissions(in percent) in Low income in 1962 to that in 1964?
Offer a very short reply. 0.73. What is the ratio of the Emissions(in percent) in Australia in 1962 to that in 1964?
Ensure brevity in your answer.  1.05. What is the ratio of the Emissions(in percent) in Congo (Democratic) in 1962 to that in 1964?
Your answer should be compact. 0.81. What is the ratio of the Emissions(in percent) of Ethiopia in 1962 to that in 1964?
Offer a terse response. 6.17. What is the ratio of the Emissions(in percent) in Low income in 1962 to that in 1965?
Keep it short and to the point. 0.75. What is the ratio of the Emissions(in percent) of Australia in 1962 to that in 1965?
Offer a terse response. 1.1. What is the ratio of the Emissions(in percent) of Congo (Democratic) in 1962 to that in 1965?
Give a very brief answer. 0.81. What is the ratio of the Emissions(in percent) of Ethiopia in 1962 to that in 1965?
Offer a terse response. 1.4. What is the ratio of the Emissions(in percent) in Low income in 1962 to that in 1966?
Ensure brevity in your answer.  0.69. What is the ratio of the Emissions(in percent) of Australia in 1962 to that in 1966?
Offer a terse response. 1.09. What is the ratio of the Emissions(in percent) in Congo (Democratic) in 1962 to that in 1966?
Provide a succinct answer. 1.02. What is the ratio of the Emissions(in percent) of Ethiopia in 1962 to that in 1966?
Your answer should be very brief. 1.79. What is the ratio of the Emissions(in percent) of Low income in 1962 to that in 1967?
Make the answer very short. 0.79. What is the ratio of the Emissions(in percent) in Australia in 1962 to that in 1967?
Provide a short and direct response. 1.11. What is the ratio of the Emissions(in percent) in Congo (Democratic) in 1962 to that in 1967?
Provide a succinct answer. 0.93. What is the ratio of the Emissions(in percent) of Ethiopia in 1962 to that in 1967?
Keep it short and to the point. 16.28. What is the ratio of the Emissions(in percent) in Low income in 1962 to that in 1968?
Provide a short and direct response. 0.86. What is the ratio of the Emissions(in percent) in Australia in 1962 to that in 1968?
Provide a succinct answer. 1.14. What is the ratio of the Emissions(in percent) of Congo (Democratic) in 1962 to that in 1968?
Provide a succinct answer. 1.76. What is the ratio of the Emissions(in percent) of Ethiopia in 1962 to that in 1968?
Provide a succinct answer. 6.54. What is the ratio of the Emissions(in percent) in Low income in 1962 to that in 1969?
Provide a succinct answer. 0.92. What is the ratio of the Emissions(in percent) of Australia in 1962 to that in 1969?
Your answer should be compact. 1.18. What is the ratio of the Emissions(in percent) of Congo (Democratic) in 1962 to that in 1969?
Offer a terse response. 1.59. What is the ratio of the Emissions(in percent) of Ethiopia in 1962 to that in 1969?
Ensure brevity in your answer.  3.61. What is the ratio of the Emissions(in percent) of Low income in 1963 to that in 1964?
Offer a terse response. 0.65. What is the ratio of the Emissions(in percent) in Australia in 1963 to that in 1964?
Provide a succinct answer. 1.02. What is the ratio of the Emissions(in percent) of Congo (Democratic) in 1963 to that in 1964?
Ensure brevity in your answer.  0.75. What is the ratio of the Emissions(in percent) of Ethiopia in 1963 to that in 1964?
Ensure brevity in your answer.  6.76. What is the ratio of the Emissions(in percent) of Low income in 1963 to that in 1965?
Provide a short and direct response. 0.68. What is the ratio of the Emissions(in percent) of Australia in 1963 to that in 1965?
Offer a terse response. 1.07. What is the ratio of the Emissions(in percent) of Congo (Democratic) in 1963 to that in 1965?
Provide a succinct answer. 0.75. What is the ratio of the Emissions(in percent) in Ethiopia in 1963 to that in 1965?
Keep it short and to the point. 1.53. What is the ratio of the Emissions(in percent) in Low income in 1963 to that in 1966?
Provide a short and direct response. 0.62. What is the ratio of the Emissions(in percent) of Australia in 1963 to that in 1966?
Your answer should be compact. 1.06. What is the ratio of the Emissions(in percent) of Congo (Democratic) in 1963 to that in 1966?
Ensure brevity in your answer.  0.94. What is the ratio of the Emissions(in percent) in Ethiopia in 1963 to that in 1966?
Your response must be concise. 1.96. What is the ratio of the Emissions(in percent) in Low income in 1963 to that in 1967?
Your answer should be very brief. 0.71. What is the ratio of the Emissions(in percent) in Australia in 1963 to that in 1967?
Make the answer very short. 1.08. What is the ratio of the Emissions(in percent) in Congo (Democratic) in 1963 to that in 1967?
Provide a succinct answer. 0.86. What is the ratio of the Emissions(in percent) in Ethiopia in 1963 to that in 1967?
Your answer should be very brief. 17.83. What is the ratio of the Emissions(in percent) in Low income in 1963 to that in 1968?
Give a very brief answer. 0.77. What is the ratio of the Emissions(in percent) in Australia in 1963 to that in 1968?
Make the answer very short. 1.11. What is the ratio of the Emissions(in percent) in Congo (Democratic) in 1963 to that in 1968?
Your answer should be compact. 1.62. What is the ratio of the Emissions(in percent) in Ethiopia in 1963 to that in 1968?
Make the answer very short. 7.17. What is the ratio of the Emissions(in percent) of Low income in 1963 to that in 1969?
Your answer should be compact. 0.83. What is the ratio of the Emissions(in percent) in Australia in 1963 to that in 1969?
Offer a terse response. 1.15. What is the ratio of the Emissions(in percent) in Congo (Democratic) in 1963 to that in 1969?
Ensure brevity in your answer.  1.47. What is the ratio of the Emissions(in percent) in Ethiopia in 1963 to that in 1969?
Provide a succinct answer. 3.96. What is the ratio of the Emissions(in percent) of Low income in 1964 to that in 1965?
Provide a short and direct response. 1.03. What is the ratio of the Emissions(in percent) of Australia in 1964 to that in 1965?
Offer a terse response. 1.05. What is the ratio of the Emissions(in percent) in Ethiopia in 1964 to that in 1965?
Keep it short and to the point. 0.23. What is the ratio of the Emissions(in percent) of Low income in 1964 to that in 1966?
Keep it short and to the point. 0.95. What is the ratio of the Emissions(in percent) in Australia in 1964 to that in 1966?
Ensure brevity in your answer.  1.04. What is the ratio of the Emissions(in percent) of Congo (Democratic) in 1964 to that in 1966?
Give a very brief answer. 1.26. What is the ratio of the Emissions(in percent) in Ethiopia in 1964 to that in 1966?
Offer a terse response. 0.29. What is the ratio of the Emissions(in percent) of Low income in 1964 to that in 1967?
Your answer should be very brief. 1.09. What is the ratio of the Emissions(in percent) in Australia in 1964 to that in 1967?
Your answer should be very brief. 1.06. What is the ratio of the Emissions(in percent) in Congo (Democratic) in 1964 to that in 1967?
Keep it short and to the point. 1.15. What is the ratio of the Emissions(in percent) of Ethiopia in 1964 to that in 1967?
Ensure brevity in your answer.  2.64. What is the ratio of the Emissions(in percent) in Low income in 1964 to that in 1968?
Your response must be concise. 1.17. What is the ratio of the Emissions(in percent) of Australia in 1964 to that in 1968?
Make the answer very short. 1.08. What is the ratio of the Emissions(in percent) in Congo (Democratic) in 1964 to that in 1968?
Keep it short and to the point. 2.16. What is the ratio of the Emissions(in percent) of Ethiopia in 1964 to that in 1968?
Give a very brief answer. 1.06. What is the ratio of the Emissions(in percent) of Low income in 1964 to that in 1969?
Provide a short and direct response. 1.26. What is the ratio of the Emissions(in percent) of Australia in 1964 to that in 1969?
Offer a very short reply. 1.12. What is the ratio of the Emissions(in percent) in Congo (Democratic) in 1964 to that in 1969?
Ensure brevity in your answer.  1.95. What is the ratio of the Emissions(in percent) in Ethiopia in 1964 to that in 1969?
Make the answer very short. 0.59. What is the ratio of the Emissions(in percent) of Low income in 1965 to that in 1966?
Your answer should be compact. 0.92. What is the ratio of the Emissions(in percent) in Congo (Democratic) in 1965 to that in 1966?
Provide a succinct answer. 1.26. What is the ratio of the Emissions(in percent) in Ethiopia in 1965 to that in 1966?
Make the answer very short. 1.28. What is the ratio of the Emissions(in percent) in Low income in 1965 to that in 1967?
Your answer should be very brief. 1.05. What is the ratio of the Emissions(in percent) in Congo (Democratic) in 1965 to that in 1967?
Provide a short and direct response. 1.15. What is the ratio of the Emissions(in percent) in Ethiopia in 1965 to that in 1967?
Offer a very short reply. 11.65. What is the ratio of the Emissions(in percent) of Low income in 1965 to that in 1968?
Your response must be concise. 1.14. What is the ratio of the Emissions(in percent) of Australia in 1965 to that in 1968?
Your answer should be compact. 1.03. What is the ratio of the Emissions(in percent) of Congo (Democratic) in 1965 to that in 1968?
Keep it short and to the point. 2.17. What is the ratio of the Emissions(in percent) in Ethiopia in 1965 to that in 1968?
Ensure brevity in your answer.  4.68. What is the ratio of the Emissions(in percent) of Low income in 1965 to that in 1969?
Offer a terse response. 1.22. What is the ratio of the Emissions(in percent) of Australia in 1965 to that in 1969?
Your answer should be compact. 1.07. What is the ratio of the Emissions(in percent) in Congo (Democratic) in 1965 to that in 1969?
Keep it short and to the point. 1.97. What is the ratio of the Emissions(in percent) in Ethiopia in 1965 to that in 1969?
Make the answer very short. 2.59. What is the ratio of the Emissions(in percent) of Low income in 1966 to that in 1967?
Keep it short and to the point. 1.15. What is the ratio of the Emissions(in percent) in Australia in 1966 to that in 1967?
Provide a short and direct response. 1.02. What is the ratio of the Emissions(in percent) of Congo (Democratic) in 1966 to that in 1967?
Keep it short and to the point. 0.91. What is the ratio of the Emissions(in percent) in Ethiopia in 1966 to that in 1967?
Offer a terse response. 9.12. What is the ratio of the Emissions(in percent) of Low income in 1966 to that in 1968?
Provide a succinct answer. 1.24. What is the ratio of the Emissions(in percent) of Australia in 1966 to that in 1968?
Your response must be concise. 1.04. What is the ratio of the Emissions(in percent) in Congo (Democratic) in 1966 to that in 1968?
Provide a short and direct response. 1.72. What is the ratio of the Emissions(in percent) of Ethiopia in 1966 to that in 1968?
Your response must be concise. 3.66. What is the ratio of the Emissions(in percent) in Low income in 1966 to that in 1969?
Offer a terse response. 1.33. What is the ratio of the Emissions(in percent) of Australia in 1966 to that in 1969?
Your answer should be very brief. 1.08. What is the ratio of the Emissions(in percent) of Congo (Democratic) in 1966 to that in 1969?
Your response must be concise. 1.56. What is the ratio of the Emissions(in percent) of Ethiopia in 1966 to that in 1969?
Your answer should be very brief. 2.02. What is the ratio of the Emissions(in percent) in Low income in 1967 to that in 1968?
Offer a terse response. 1.08. What is the ratio of the Emissions(in percent) in Australia in 1967 to that in 1968?
Your answer should be very brief. 1.03. What is the ratio of the Emissions(in percent) in Congo (Democratic) in 1967 to that in 1968?
Keep it short and to the point. 1.89. What is the ratio of the Emissions(in percent) of Ethiopia in 1967 to that in 1968?
Ensure brevity in your answer.  0.4. What is the ratio of the Emissions(in percent) in Low income in 1967 to that in 1969?
Give a very brief answer. 1.16. What is the ratio of the Emissions(in percent) of Australia in 1967 to that in 1969?
Your answer should be very brief. 1.06. What is the ratio of the Emissions(in percent) in Congo (Democratic) in 1967 to that in 1969?
Provide a succinct answer. 1.71. What is the ratio of the Emissions(in percent) in Ethiopia in 1967 to that in 1969?
Provide a short and direct response. 0.22. What is the ratio of the Emissions(in percent) in Low income in 1968 to that in 1969?
Your response must be concise. 1.08. What is the ratio of the Emissions(in percent) in Australia in 1968 to that in 1969?
Offer a very short reply. 1.04. What is the ratio of the Emissions(in percent) of Congo (Democratic) in 1968 to that in 1969?
Make the answer very short. 0.9. What is the ratio of the Emissions(in percent) of Ethiopia in 1968 to that in 1969?
Give a very brief answer. 0.55. What is the difference between the highest and the second highest Emissions(in percent) of Low income?
Your answer should be very brief. 2.04. What is the difference between the highest and the second highest Emissions(in percent) in Australia?
Your answer should be very brief. 1.7. What is the difference between the highest and the second highest Emissions(in percent) in Congo (Democratic)?
Offer a terse response. 0.28. What is the difference between the highest and the second highest Emissions(in percent) in Ethiopia?
Provide a short and direct response. 0.53. What is the difference between the highest and the lowest Emissions(in percent) in Low income?
Offer a very short reply. 15.42. What is the difference between the highest and the lowest Emissions(in percent) in Australia?
Your response must be concise. 9.98. What is the difference between the highest and the lowest Emissions(in percent) in Congo (Democratic)?
Your answer should be very brief. 25.79. What is the difference between the highest and the lowest Emissions(in percent) of Ethiopia?
Offer a very short reply. 5.75. 